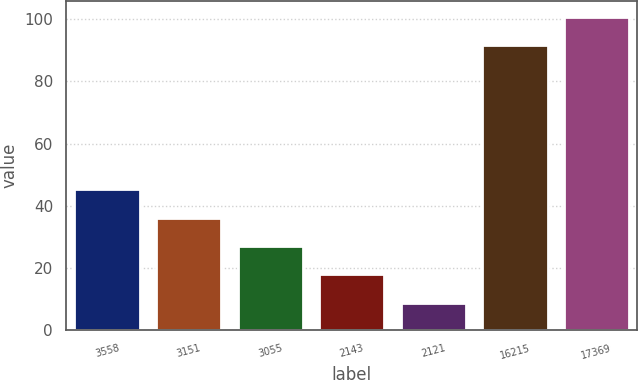<chart> <loc_0><loc_0><loc_500><loc_500><bar_chart><fcel>3558<fcel>3151<fcel>3055<fcel>2143<fcel>2121<fcel>16215<fcel>17369<nl><fcel>45.22<fcel>36.09<fcel>26.96<fcel>17.83<fcel>8.7<fcel>91.8<fcel>100.93<nl></chart> 